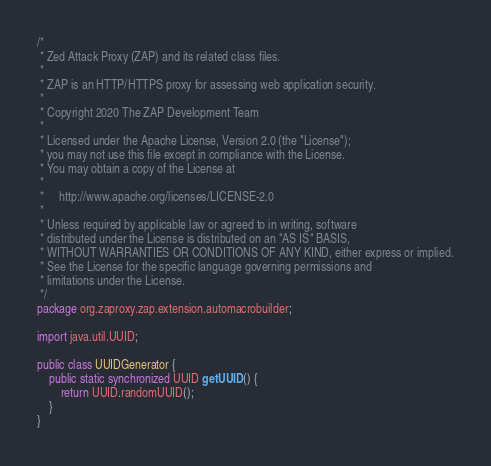<code> <loc_0><loc_0><loc_500><loc_500><_Java_>/*
 * Zed Attack Proxy (ZAP) and its related class files.
 *
 * ZAP is an HTTP/HTTPS proxy for assessing web application security.
 *
 * Copyright 2020 The ZAP Development Team
 *
 * Licensed under the Apache License, Version 2.0 (the "License");
 * you may not use this file except in compliance with the License.
 * You may obtain a copy of the License at
 *
 *     http://www.apache.org/licenses/LICENSE-2.0
 *
 * Unless required by applicable law or agreed to in writing, software
 * distributed under the License is distributed on an "AS IS" BASIS,
 * WITHOUT WARRANTIES OR CONDITIONS OF ANY KIND, either express or implied.
 * See the License for the specific language governing permissions and
 * limitations under the License.
 */
package org.zaproxy.zap.extension.automacrobuilder;

import java.util.UUID;

public class UUIDGenerator {
    public static synchronized UUID getUUID() {
        return UUID.randomUUID();
    }
}
</code> 